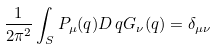Convert formula to latex. <formula><loc_0><loc_0><loc_500><loc_500>\frac { 1 } { 2 \pi ^ { 2 } } \int _ { S } P _ { \mu } ( q ) D \, q G _ { \nu } ( q ) = \delta _ { \mu \nu }</formula> 